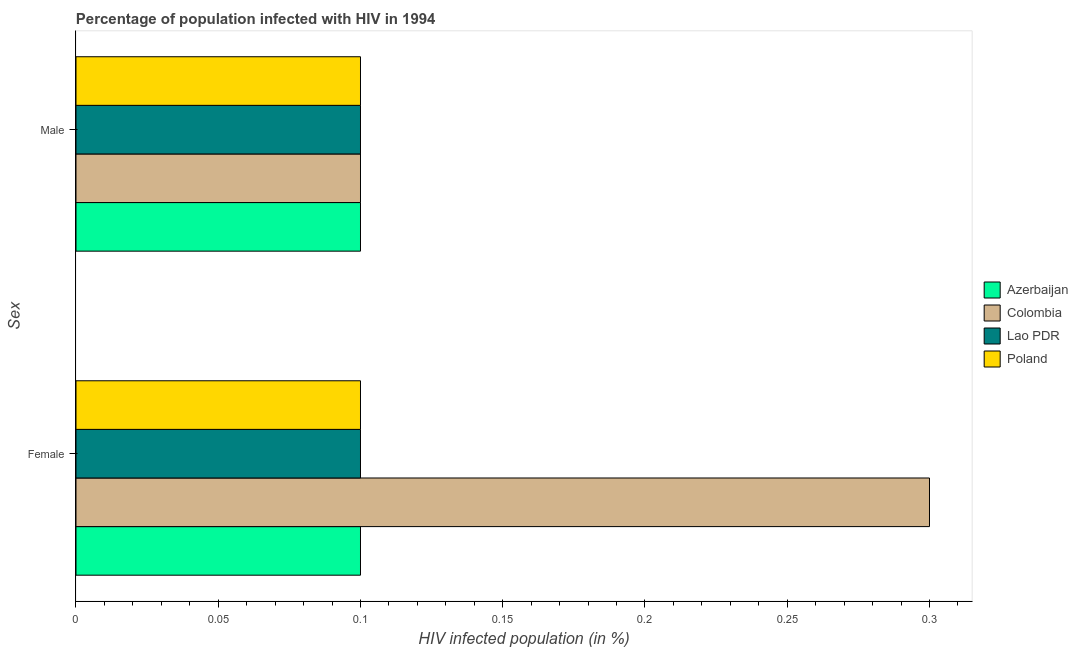Are the number of bars on each tick of the Y-axis equal?
Your response must be concise. Yes. How many bars are there on the 1st tick from the top?
Offer a terse response. 4. How many bars are there on the 1st tick from the bottom?
Offer a very short reply. 4. What is the label of the 1st group of bars from the top?
Give a very brief answer. Male. What is the percentage of females who are infected with hiv in Lao PDR?
Offer a terse response. 0.1. In which country was the percentage of males who are infected with hiv maximum?
Provide a short and direct response. Azerbaijan. In which country was the percentage of males who are infected with hiv minimum?
Keep it short and to the point. Azerbaijan. What is the total percentage of males who are infected with hiv in the graph?
Provide a short and direct response. 0.4. What is the difference between the percentage of females who are infected with hiv in Poland and that in Colombia?
Give a very brief answer. -0.2. What is the difference between the percentage of females who are infected with hiv in Azerbaijan and the percentage of males who are infected with hiv in Poland?
Give a very brief answer. 0. What is the average percentage of females who are infected with hiv per country?
Give a very brief answer. 0.15. What is the difference between the percentage of females who are infected with hiv and percentage of males who are infected with hiv in Colombia?
Provide a short and direct response. 0.2. What is the ratio of the percentage of females who are infected with hiv in Poland to that in Colombia?
Ensure brevity in your answer.  0.33. In how many countries, is the percentage of females who are infected with hiv greater than the average percentage of females who are infected with hiv taken over all countries?
Provide a succinct answer. 1. What does the 3rd bar from the bottom in Female represents?
Your response must be concise. Lao PDR. How many bars are there?
Give a very brief answer. 8. Are all the bars in the graph horizontal?
Ensure brevity in your answer.  Yes. Where does the legend appear in the graph?
Make the answer very short. Center right. How many legend labels are there?
Your answer should be very brief. 4. How are the legend labels stacked?
Provide a short and direct response. Vertical. What is the title of the graph?
Offer a very short reply. Percentage of population infected with HIV in 1994. What is the label or title of the X-axis?
Your answer should be very brief. HIV infected population (in %). What is the label or title of the Y-axis?
Give a very brief answer. Sex. What is the HIV infected population (in %) in Azerbaijan in Female?
Your answer should be compact. 0.1. What is the HIV infected population (in %) in Lao PDR in Female?
Provide a succinct answer. 0.1. Across all Sex, what is the maximum HIV infected population (in %) in Colombia?
Your answer should be very brief. 0.3. Across all Sex, what is the maximum HIV infected population (in %) of Lao PDR?
Your response must be concise. 0.1. Across all Sex, what is the maximum HIV infected population (in %) of Poland?
Give a very brief answer. 0.1. Across all Sex, what is the minimum HIV infected population (in %) in Poland?
Your answer should be compact. 0.1. What is the total HIV infected population (in %) in Azerbaijan in the graph?
Your answer should be compact. 0.2. What is the total HIV infected population (in %) of Lao PDR in the graph?
Keep it short and to the point. 0.2. What is the difference between the HIV infected population (in %) in Azerbaijan in Female and that in Male?
Your answer should be compact. 0. What is the difference between the HIV infected population (in %) in Colombia in Female and that in Male?
Provide a succinct answer. 0.2. What is the difference between the HIV infected population (in %) of Lao PDR in Female and that in Male?
Your answer should be compact. 0. What is the difference between the HIV infected population (in %) in Poland in Female and that in Male?
Ensure brevity in your answer.  0. What is the difference between the HIV infected population (in %) in Azerbaijan in Female and the HIV infected population (in %) in Colombia in Male?
Ensure brevity in your answer.  0. What is the difference between the HIV infected population (in %) of Azerbaijan in Female and the HIV infected population (in %) of Poland in Male?
Provide a succinct answer. 0. What is the difference between the HIV infected population (in %) of Colombia in Female and the HIV infected population (in %) of Lao PDR in Male?
Make the answer very short. 0.2. What is the difference between the HIV infected population (in %) of Lao PDR in Female and the HIV infected population (in %) of Poland in Male?
Your answer should be very brief. 0. What is the average HIV infected population (in %) in Colombia per Sex?
Provide a short and direct response. 0.2. What is the average HIV infected population (in %) in Poland per Sex?
Offer a very short reply. 0.1. What is the difference between the HIV infected population (in %) of Azerbaijan and HIV infected population (in %) of Lao PDR in Female?
Make the answer very short. 0. What is the difference between the HIV infected population (in %) of Azerbaijan and HIV infected population (in %) of Poland in Female?
Your answer should be compact. 0. What is the difference between the HIV infected population (in %) in Colombia and HIV infected population (in %) in Poland in Female?
Offer a terse response. 0.2. What is the difference between the HIV infected population (in %) in Azerbaijan and HIV infected population (in %) in Colombia in Male?
Keep it short and to the point. 0. What is the difference between the HIV infected population (in %) of Colombia and HIV infected population (in %) of Poland in Male?
Ensure brevity in your answer.  0. What is the ratio of the HIV infected population (in %) of Azerbaijan in Female to that in Male?
Your answer should be compact. 1. What is the difference between the highest and the second highest HIV infected population (in %) of Azerbaijan?
Ensure brevity in your answer.  0. What is the difference between the highest and the second highest HIV infected population (in %) of Colombia?
Offer a terse response. 0.2. What is the difference between the highest and the second highest HIV infected population (in %) in Poland?
Offer a very short reply. 0. What is the difference between the highest and the lowest HIV infected population (in %) of Colombia?
Keep it short and to the point. 0.2. What is the difference between the highest and the lowest HIV infected population (in %) in Poland?
Give a very brief answer. 0. 